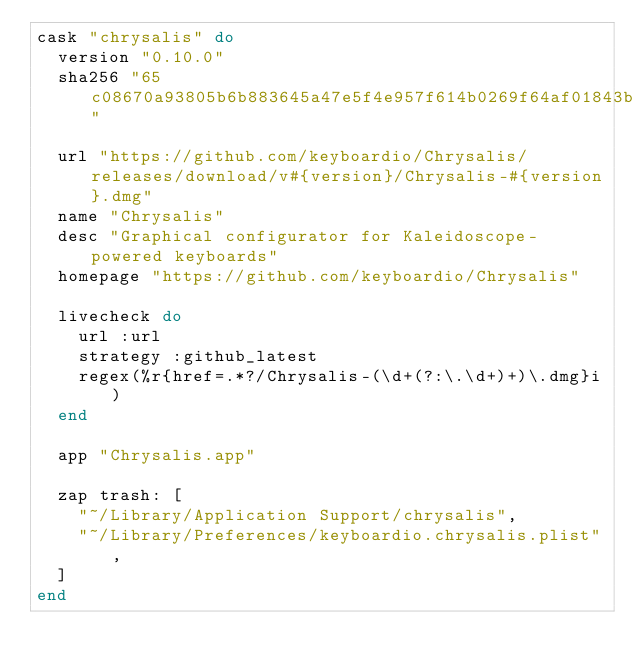<code> <loc_0><loc_0><loc_500><loc_500><_Ruby_>cask "chrysalis" do
  version "0.10.0"
  sha256 "65c08670a93805b6b883645a47e5f4e957f614b0269f64af01843b7f7284c0d9"

  url "https://github.com/keyboardio/Chrysalis/releases/download/v#{version}/Chrysalis-#{version}.dmg"
  name "Chrysalis"
  desc "Graphical configurator for Kaleidoscope-powered keyboards"
  homepage "https://github.com/keyboardio/Chrysalis"

  livecheck do
    url :url
    strategy :github_latest
    regex(%r{href=.*?/Chrysalis-(\d+(?:\.\d+)+)\.dmg}i)
  end

  app "Chrysalis.app"

  zap trash: [
    "~/Library/Application Support/chrysalis",
    "~/Library/Preferences/keyboardio.chrysalis.plist",
  ]
end
</code> 